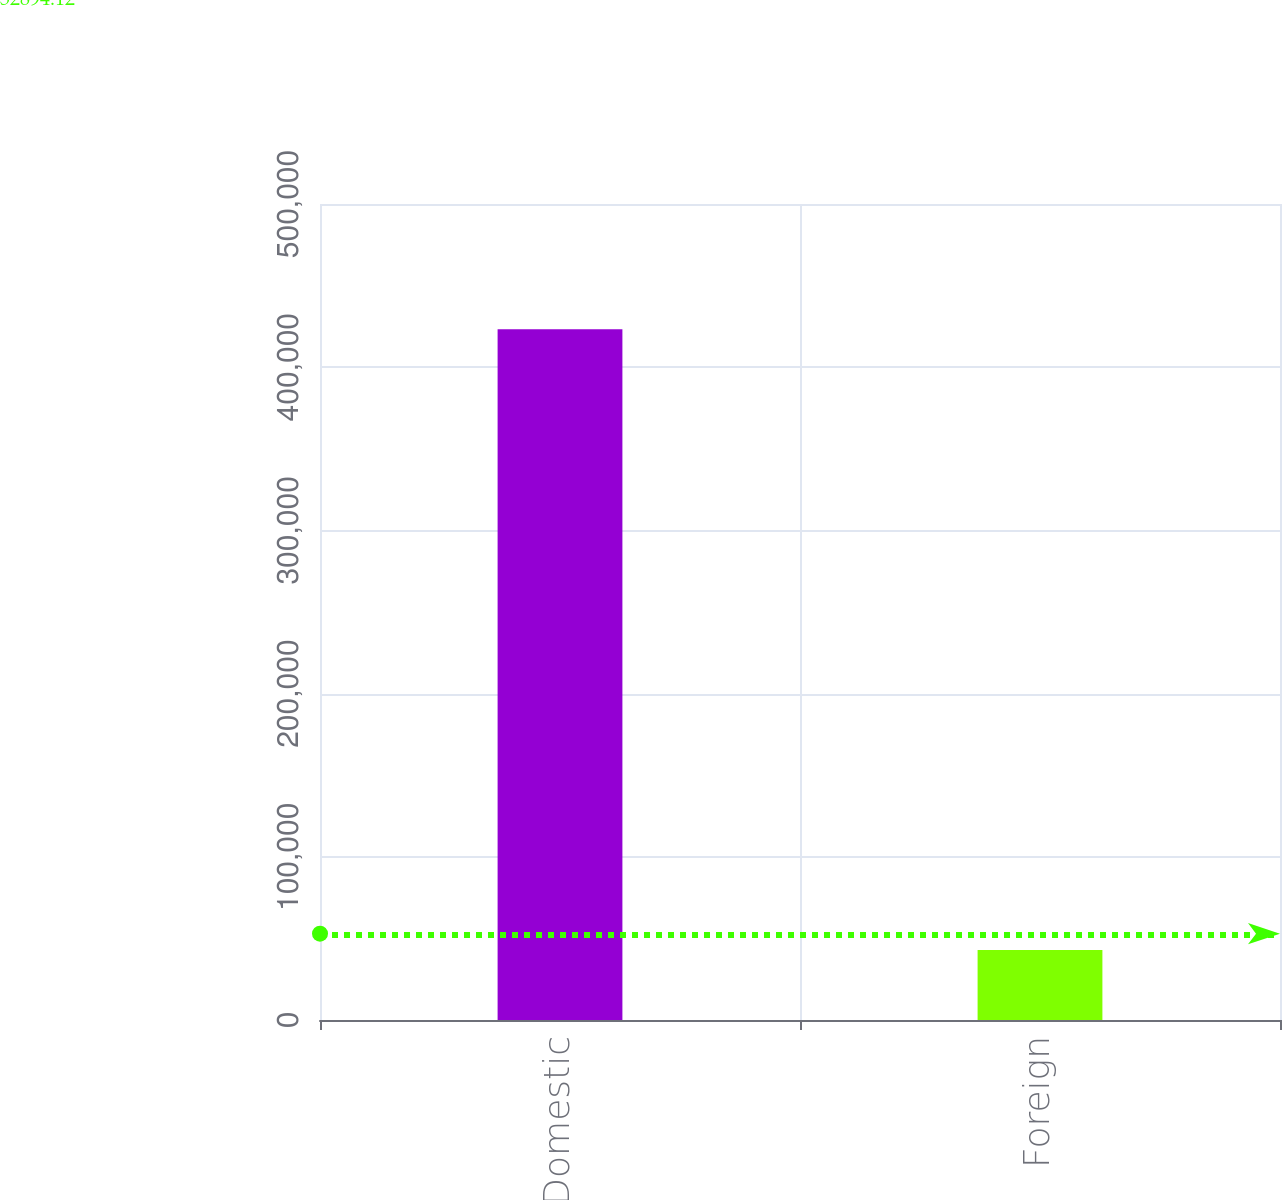<chart> <loc_0><loc_0><loc_500><loc_500><bar_chart><fcel>Domestic<fcel>Foreign<nl><fcel>423312<fcel>42890<nl></chart> 